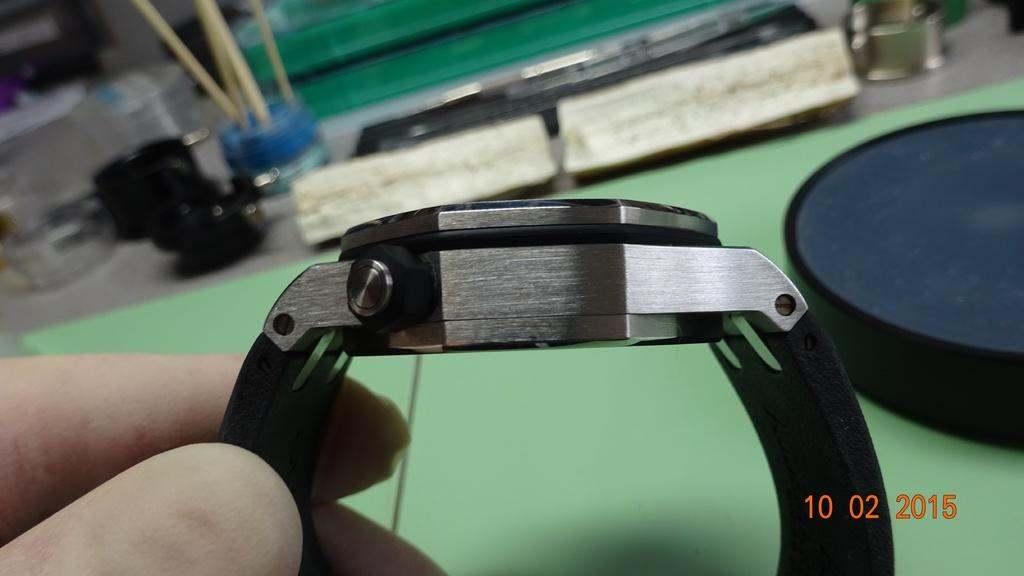What is the hand in the image holding? The hand in the image is holding a watch. Can you describe the background of the image? There are objects visible in the background of the image, but their specific details are not provided. How many girls are present in the image? There is no mention of girls in the provided facts, so it cannot be determined from the image. What type of cup can be seen in the image? There is no cup present in the image, as the facts only mention a hand holding a watch and objects in the background. 